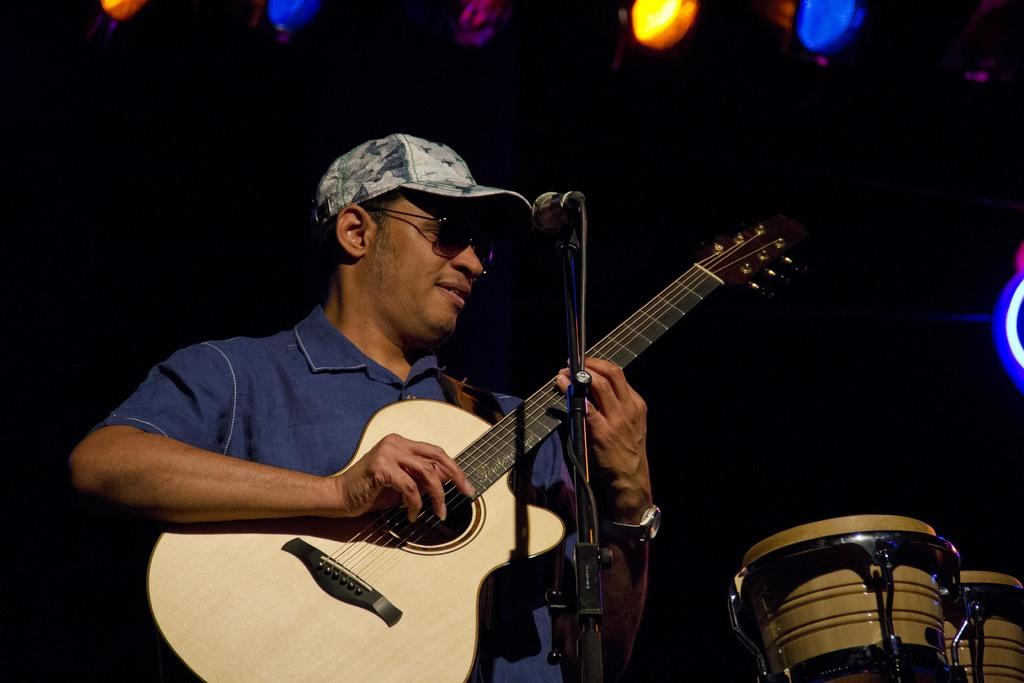Who is the main subject in the image? There is a man in the image. What is the man doing in the image? The man is standing and playing a guitar. What object is in front of the man? There is a microphone in front of the man. What other musical instrument can be seen in the image? There are drums visible in the image. What type of breakfast is the man eating in the image? There is no indication of the man eating breakfast in the image; he is playing a guitar and standing near a microphone and drums. 